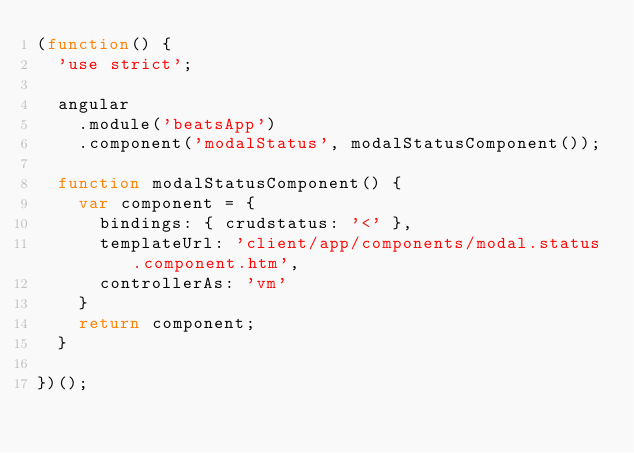<code> <loc_0><loc_0><loc_500><loc_500><_JavaScript_>(function() {
  'use strict';

  angular
    .module('beatsApp')
    .component('modalStatus', modalStatusComponent());

  function modalStatusComponent() {
    var component = {
      bindings: { crudstatus: '<' },
      templateUrl: 'client/app/components/modal.status.component.htm',
      controllerAs: 'vm'
    }
    return component;
  }

})();</code> 